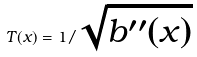<formula> <loc_0><loc_0><loc_500><loc_500>T ( x ) = 1 / \sqrt { b ^ { \prime \prime } ( x ) }</formula> 